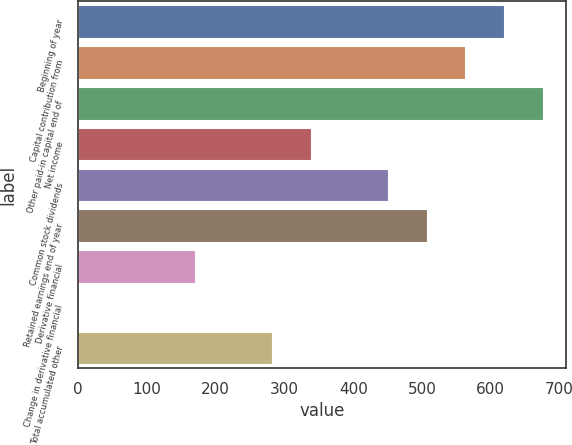Convert chart. <chart><loc_0><loc_0><loc_500><loc_500><bar_chart><fcel>Beginning of year<fcel>Capital contribution from<fcel>Other paid-in capital end of<fcel>Net income<fcel>Common stock dividends<fcel>Retained earnings end of year<fcel>Derivative financial<fcel>Change in derivative financial<fcel>Total accumulated other<nl><fcel>619.2<fcel>563<fcel>675.4<fcel>338.2<fcel>450.6<fcel>506.8<fcel>169.6<fcel>1<fcel>282<nl></chart> 